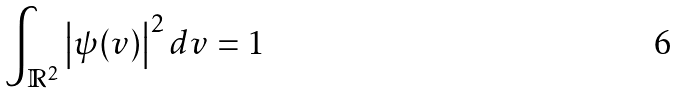Convert formula to latex. <formula><loc_0><loc_0><loc_500><loc_500>\int _ { \mathbb { R } ^ { 2 } } \left | \psi ( v ) \right | ^ { 2 } d v = 1</formula> 